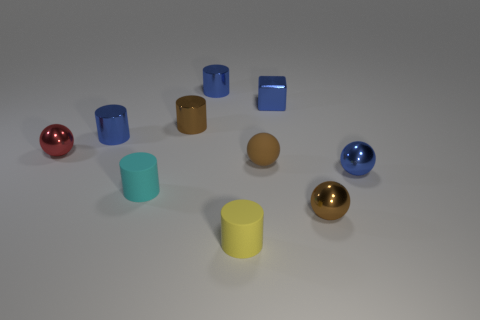How many metal things are both on the right side of the red metallic object and left of the blue metallic ball?
Offer a very short reply. 5. What number of cyan rubber objects are in front of the sphere to the right of the small brown metallic object that is in front of the blue ball?
Provide a succinct answer. 1. There is a red thing; what shape is it?
Give a very brief answer. Sphere. What number of other blocks have the same material as the blue cube?
Provide a short and direct response. 0. There is a tiny cylinder that is the same material as the small cyan object; what is its color?
Make the answer very short. Yellow. There is a yellow matte thing; is it the same size as the brown metal thing on the left side of the tiny brown rubber sphere?
Give a very brief answer. Yes. What material is the small yellow object in front of the brown thing that is behind the small shiny ball left of the blue metallic cube?
Provide a short and direct response. Rubber. How many objects are large purple matte objects or tiny objects?
Give a very brief answer. 10. There is a shiny object that is behind the tiny blue block; is its color the same as the small cube on the right side of the tiny yellow matte thing?
Your response must be concise. Yes. There is a cyan rubber object that is the same size as the blue cube; what is its shape?
Ensure brevity in your answer.  Cylinder. 